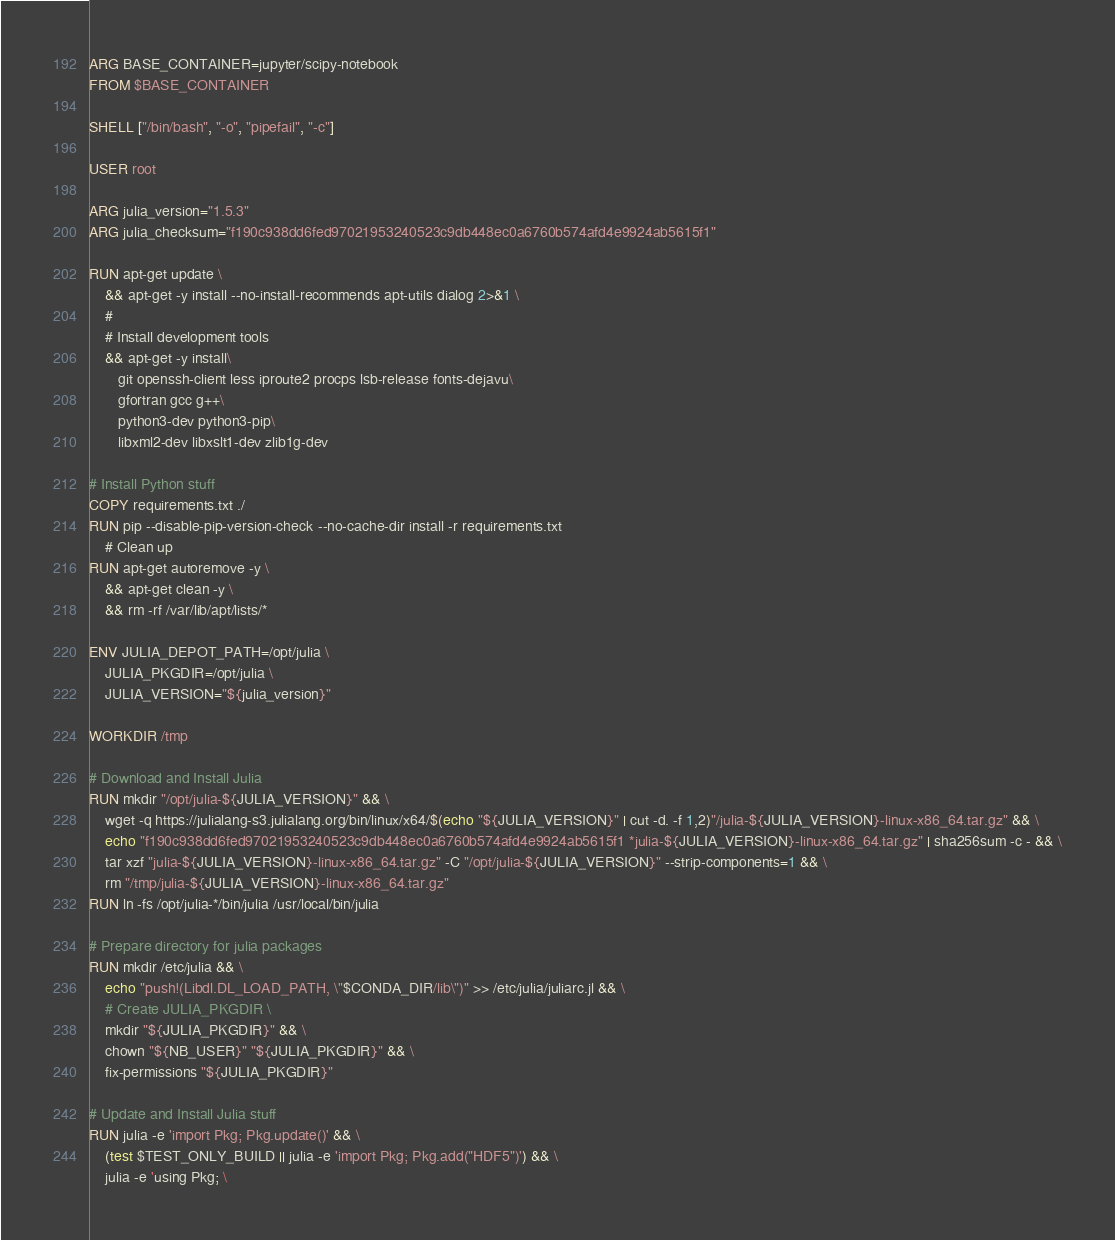Convert code to text. <code><loc_0><loc_0><loc_500><loc_500><_Dockerfile_>ARG BASE_CONTAINER=jupyter/scipy-notebook
FROM $BASE_CONTAINER

SHELL ["/bin/bash", "-o", "pipefail", "-c"]

USER root

ARG julia_version="1.5.3"
ARG julia_checksum="f190c938dd6fed97021953240523c9db448ec0a6760b574afd4e9924ab5615f1"

RUN apt-get update \
    && apt-get -y install --no-install-recommends apt-utils dialog 2>&1 \
    #
    # Install development tools
    && apt-get -y install\
       git openssh-client less iproute2 procps lsb-release fonts-dejavu\
       gfortran gcc g++\
       python3-dev python3-pip\
       libxml2-dev libxslt1-dev zlib1g-dev

# Install Python stuff
COPY requirements.txt ./
RUN pip --disable-pip-version-check --no-cache-dir install -r requirements.txt
    # Clean up
RUN apt-get autoremove -y \
    && apt-get clean -y \
    && rm -rf /var/lib/apt/lists/*

ENV JULIA_DEPOT_PATH=/opt/julia \
    JULIA_PKGDIR=/opt/julia \
    JULIA_VERSION="${julia_version}"

WORKDIR /tmp

# Download and Install Julia
RUN mkdir "/opt/julia-${JULIA_VERSION}" && \
    wget -q https://julialang-s3.julialang.org/bin/linux/x64/$(echo "${JULIA_VERSION}" | cut -d. -f 1,2)"/julia-${JULIA_VERSION}-linux-x86_64.tar.gz" && \
    echo "f190c938dd6fed97021953240523c9db448ec0a6760b574afd4e9924ab5615f1 *julia-${JULIA_VERSION}-linux-x86_64.tar.gz" | sha256sum -c - && \
    tar xzf "julia-${JULIA_VERSION}-linux-x86_64.tar.gz" -C "/opt/julia-${JULIA_VERSION}" --strip-components=1 && \
    rm "/tmp/julia-${JULIA_VERSION}-linux-x86_64.tar.gz"
RUN ln -fs /opt/julia-*/bin/julia /usr/local/bin/julia

# Prepare directory for julia packages
RUN mkdir /etc/julia && \
    echo "push!(Libdl.DL_LOAD_PATH, \"$CONDA_DIR/lib\")" >> /etc/julia/juliarc.jl && \
    # Create JULIA_PKGDIR \
    mkdir "${JULIA_PKGDIR}" && \
    chown "${NB_USER}" "${JULIA_PKGDIR}" && \
    fix-permissions "${JULIA_PKGDIR}"

# Update and Install Julia stuff
RUN julia -e 'import Pkg; Pkg.update()' && \
    (test $TEST_ONLY_BUILD || julia -e 'import Pkg; Pkg.add("HDF5")') && \
    julia -e 'using Pkg; \</code> 